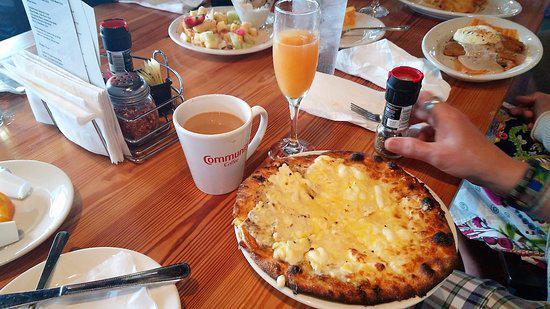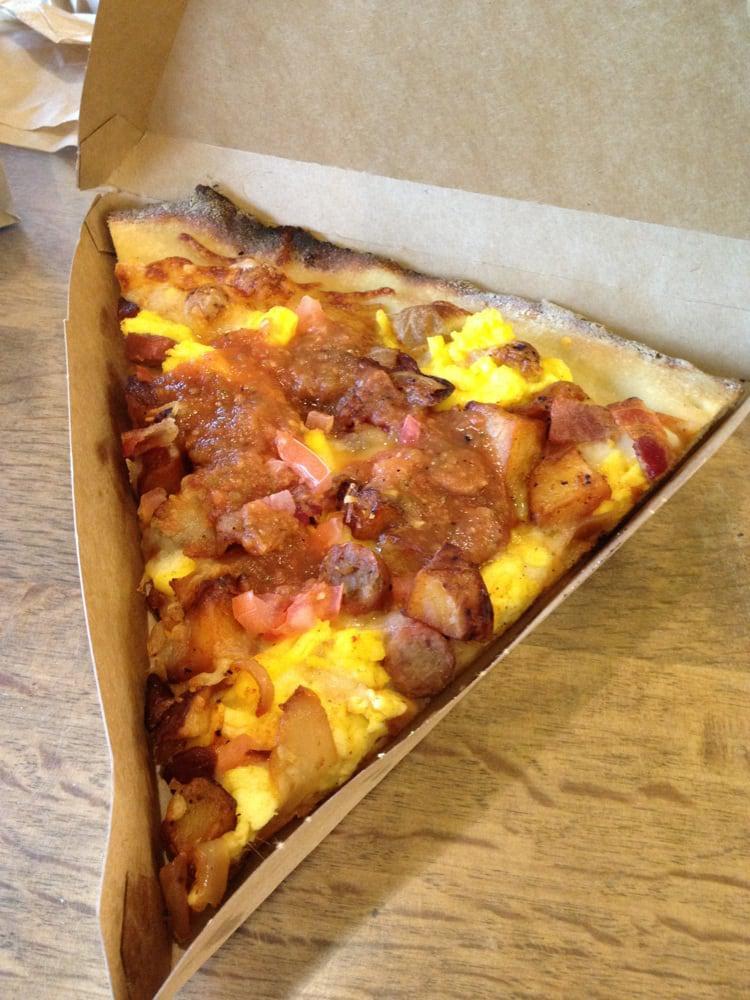The first image is the image on the left, the second image is the image on the right. For the images displayed, is the sentence "A whole pizza is on the table." factually correct? Answer yes or no. Yes. The first image is the image on the left, the second image is the image on the right. Considering the images on both sides, is "The right image shows only breakfast pizza." valid? Answer yes or no. Yes. 